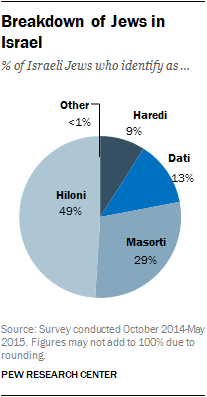Indicate a few pertinent items in this graphic. The color of the "Dati" segment in the chart is blue. 